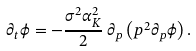Convert formula to latex. <formula><loc_0><loc_0><loc_500><loc_500>\partial _ { t } \phi = - \frac { \sigma ^ { 2 } \alpha _ { K } ^ { 2 } } { 2 } \, \partial _ { p } \left ( p ^ { 2 } \partial _ { p } \phi \right ) .</formula> 